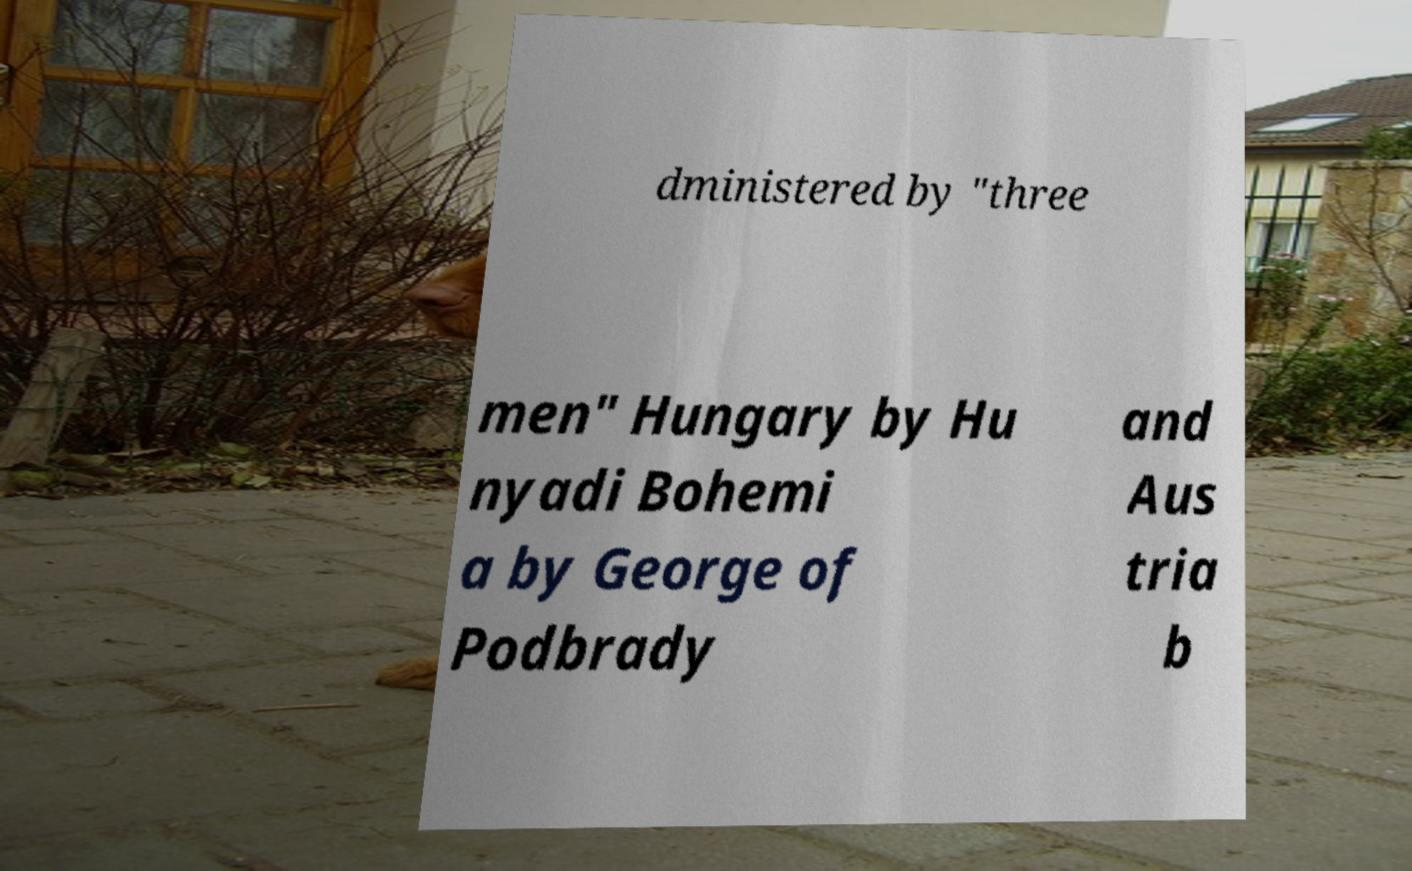There's text embedded in this image that I need extracted. Can you transcribe it verbatim? dministered by "three men" Hungary by Hu nyadi Bohemi a by George of Podbrady and Aus tria b 